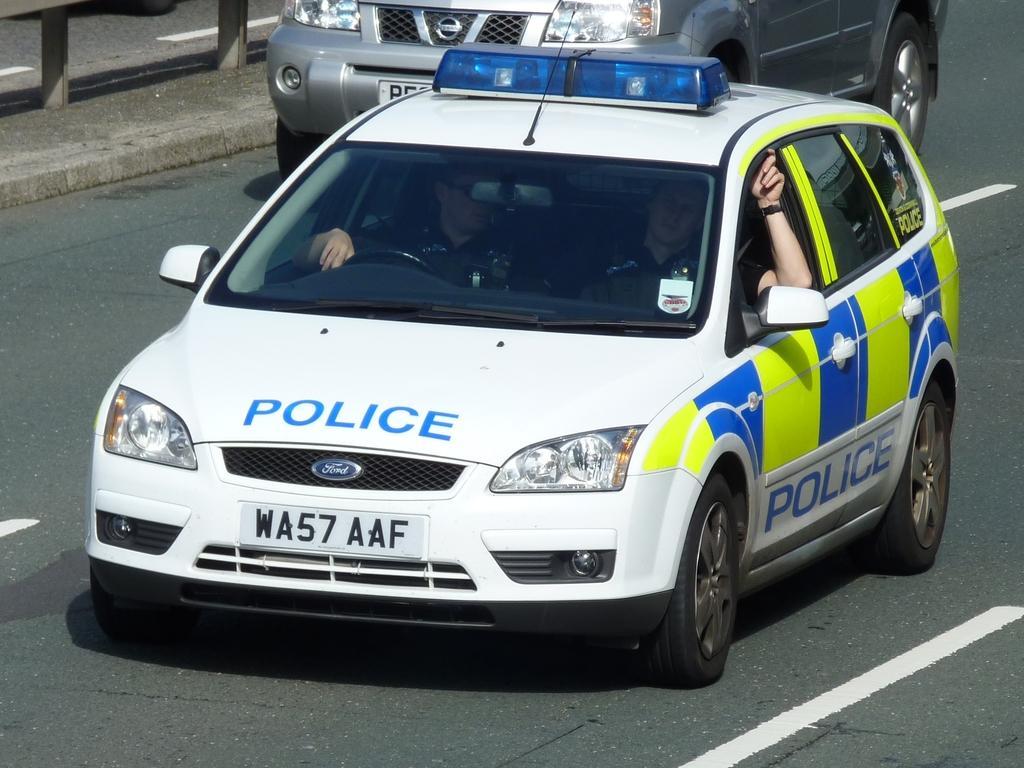Could you give a brief overview of what you see in this image? In this picture we can see few cars on the road, and few people are seated in it, and also we can see few metal rods. 